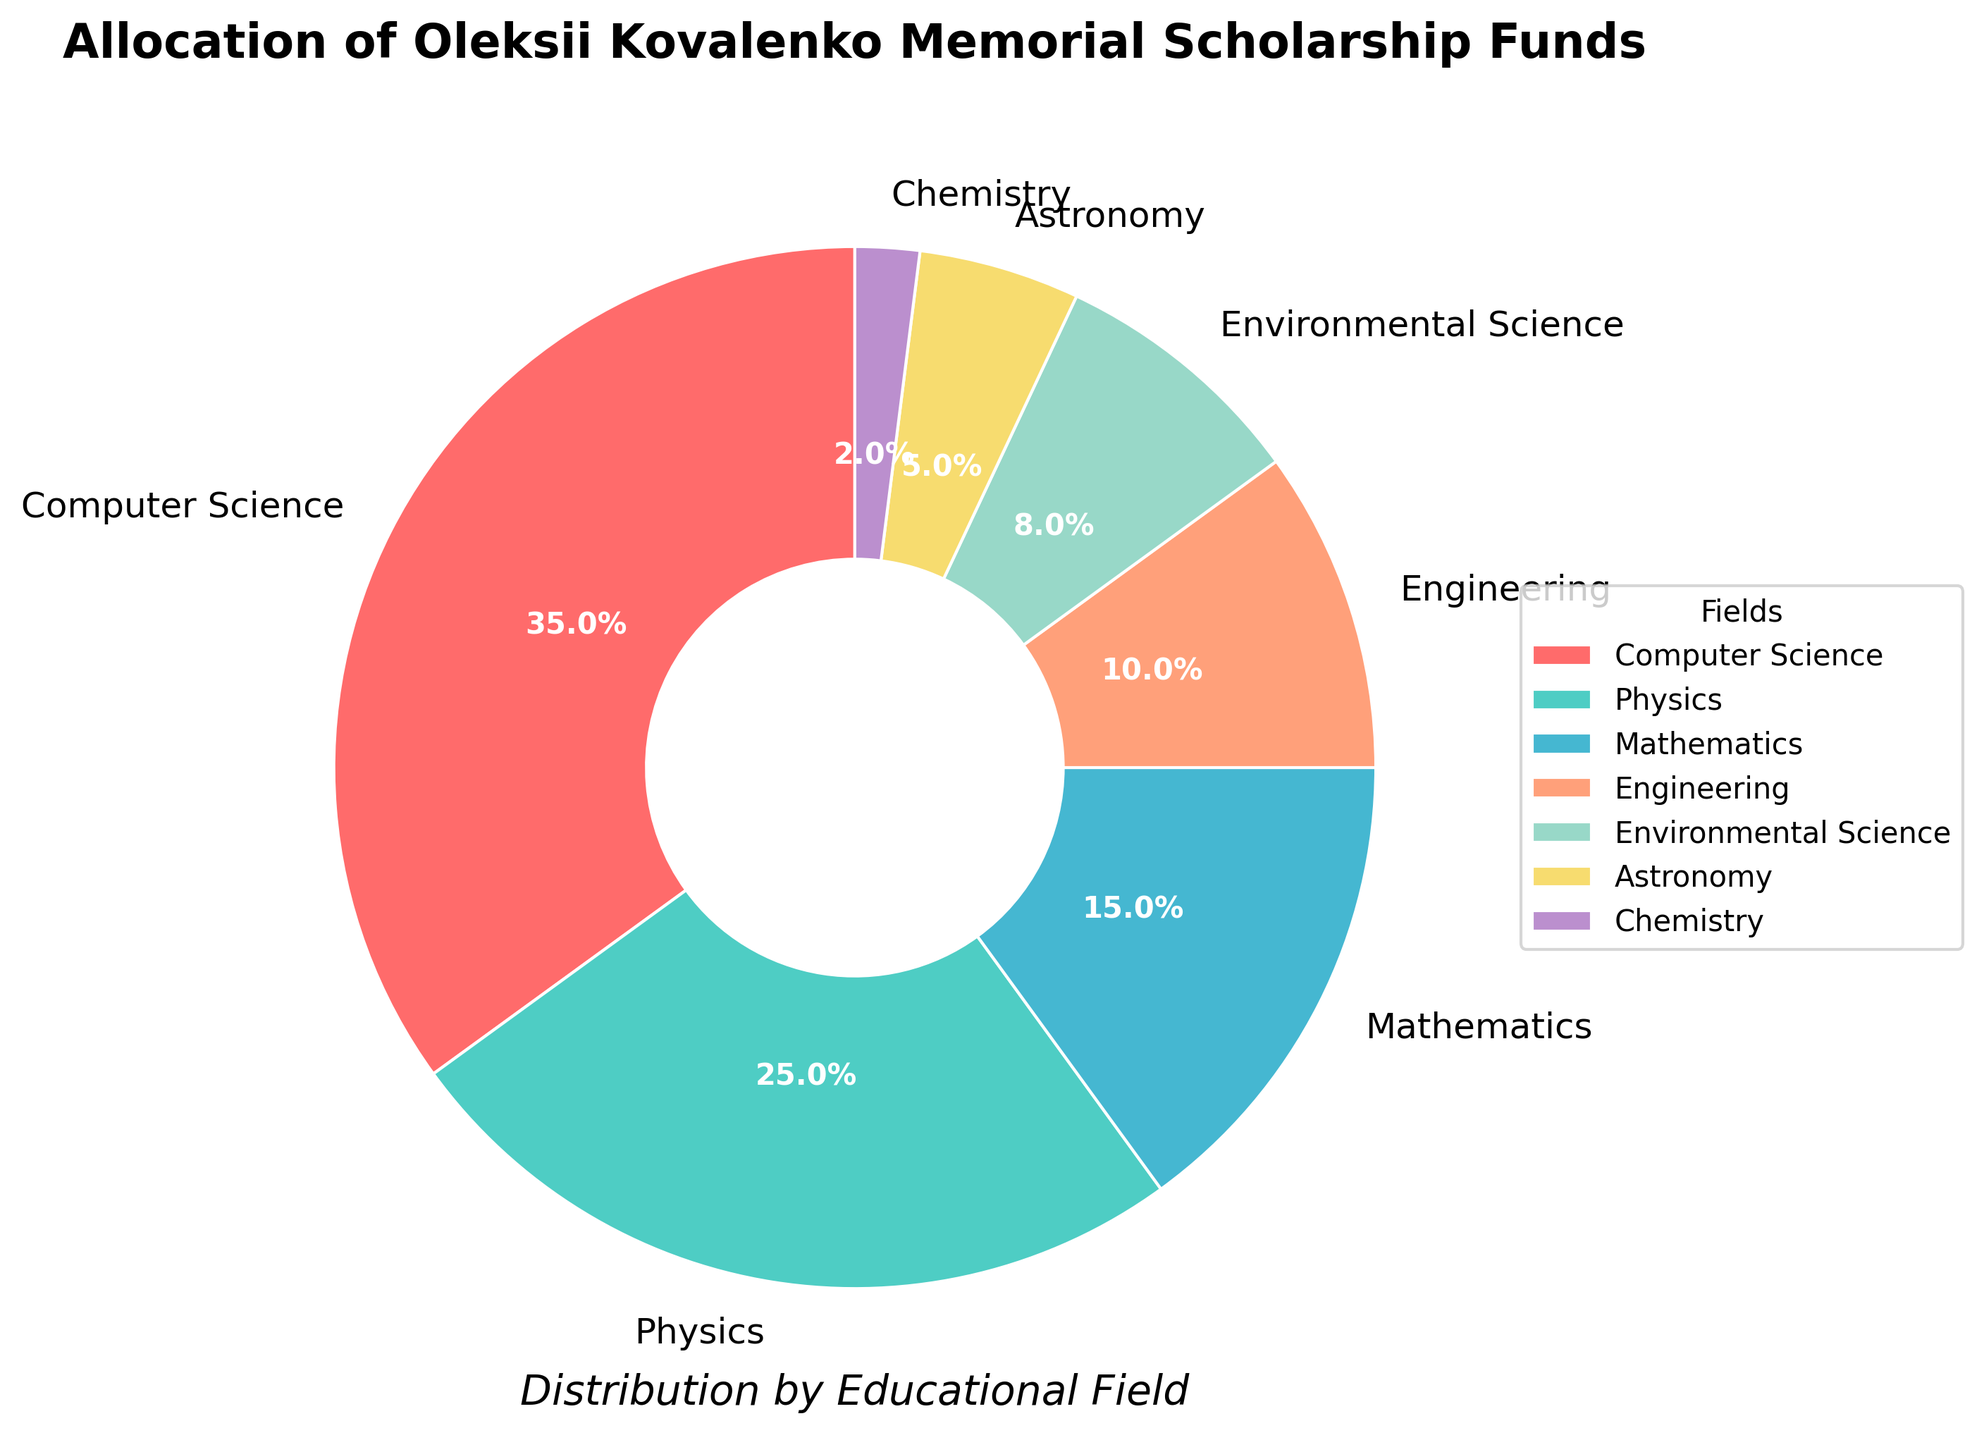Which field received the highest percentage of allocation? The highest percentage slice in the pie chart corresponds to the field with the greatest allocation. From the chart, Computer Science has the largest slice at 35%.
Answer: Computer Science What's the combined percentage of funds allocated to Physics and Mathematics? Add the percentages of Physics and Mathematics together. Physics has 25% and Mathematics has 15%. So, 25% + 15% = 40%.
Answer: 40% How much more percentage is allocated to Environmental Science compared to Chemistry? Subtract the percentage for Chemistry from the percentage for Environmental Science. Environmental Science has 8% and Chemistry has 2%, so 8% - 2% = 6%.
Answer: 6% Which fields have a percentage of allocation that is less than 10%? Identify the fields with less than 10% allocation by examining the chart. The fields are Engineering (10%), Environmental Science (8%), Astronomy (5%), and Chemistry (2%).
Answer: Environmental Science, Astronomy, Chemistry Is the percentage allocated to Computer Science greater than the combined allocation of Astronomy and Chemistry? Compare the percentage of Computer Science (35%) against the sum of Astronomy (5%) and Chemistry (2%), which is 5% + 2% = 7%. Since 35% > 7%, the allocation to Computer Science is indeed greater.
Answer: Yes Which field received the smallest percentage of funds? The smallest percentage slice in the pie chart corresponds to the field with the least allocation. From the chart, Chemistry has the smallest slice at 2%.
Answer: Chemistry What fraction of the total funds is allocated to Engineering and Environmental Science combined? Add the percentages of Engineering (10%) and Environmental Science (8%) together for the combined fraction of funds. 10% + 8% = 18%. As a fraction of the total funds (which is 100%), it is 18/100. Simplified, this is 9/50.
Answer: 9/50 Compare the allocation for Physics and Mathematics. Which one has a higher allocation? Compare the percentage values for Physics (25%) and Mathematics (15%). Since 25% > 15%, Physics has a higher allocation.
Answer: Physics How does the allocation to Astronomy compare with that of Environmental Science? Is it more or less? Identify the percentages for Astronomy (5%) and Environmental Science (8%) and compare them. Since 8% > 5%, Astronomy has a lower allocation compared to Environmental Science.
Answer: Less 